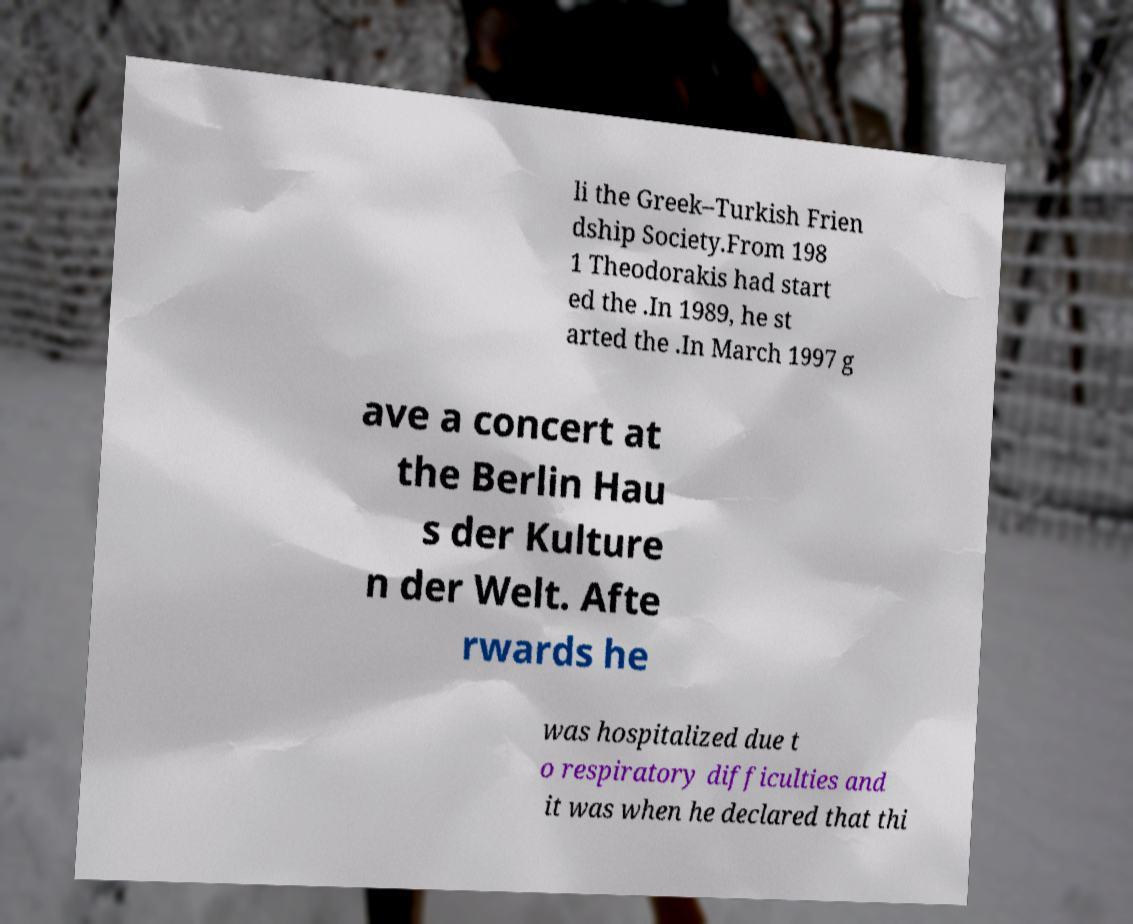I need the written content from this picture converted into text. Can you do that? li the Greek–Turkish Frien dship Society.From 198 1 Theodorakis had start ed the .In 1989, he st arted the .In March 1997 g ave a concert at the Berlin Hau s der Kulture n der Welt. Afte rwards he was hospitalized due t o respiratory difficulties and it was when he declared that thi 